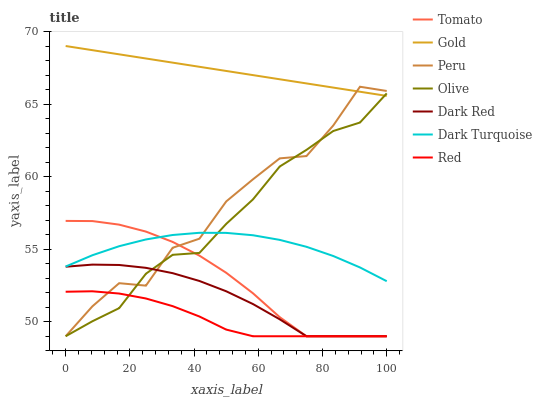Does Red have the minimum area under the curve?
Answer yes or no. Yes. Does Gold have the maximum area under the curve?
Answer yes or no. Yes. Does Dark Turquoise have the minimum area under the curve?
Answer yes or no. No. Does Dark Turquoise have the maximum area under the curve?
Answer yes or no. No. Is Gold the smoothest?
Answer yes or no. Yes. Is Peru the roughest?
Answer yes or no. Yes. Is Dark Turquoise the smoothest?
Answer yes or no. No. Is Dark Turquoise the roughest?
Answer yes or no. No. Does Tomato have the lowest value?
Answer yes or no. Yes. Does Dark Turquoise have the lowest value?
Answer yes or no. No. Does Gold have the highest value?
Answer yes or no. Yes. Does Dark Turquoise have the highest value?
Answer yes or no. No. Is Red less than Dark Turquoise?
Answer yes or no. Yes. Is Gold greater than Red?
Answer yes or no. Yes. Does Olive intersect Tomato?
Answer yes or no. Yes. Is Olive less than Tomato?
Answer yes or no. No. Is Olive greater than Tomato?
Answer yes or no. No. Does Red intersect Dark Turquoise?
Answer yes or no. No. 